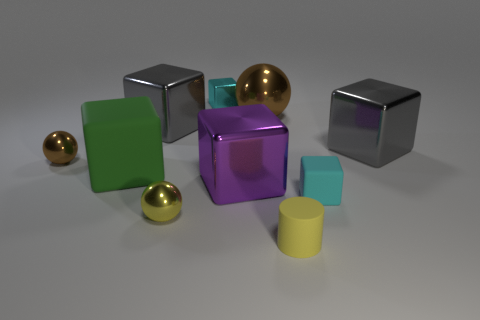Subtract all purple cubes. How many cubes are left? 5 Subtract all small rubber blocks. How many blocks are left? 5 Subtract all brown cubes. Subtract all cyan cylinders. How many cubes are left? 6 Subtract all blocks. How many objects are left? 4 Subtract all big blocks. Subtract all matte blocks. How many objects are left? 4 Add 9 tiny cyan rubber cubes. How many tiny cyan rubber cubes are left? 10 Add 2 big cyan rubber things. How many big cyan rubber things exist? 2 Subtract 0 gray spheres. How many objects are left? 10 